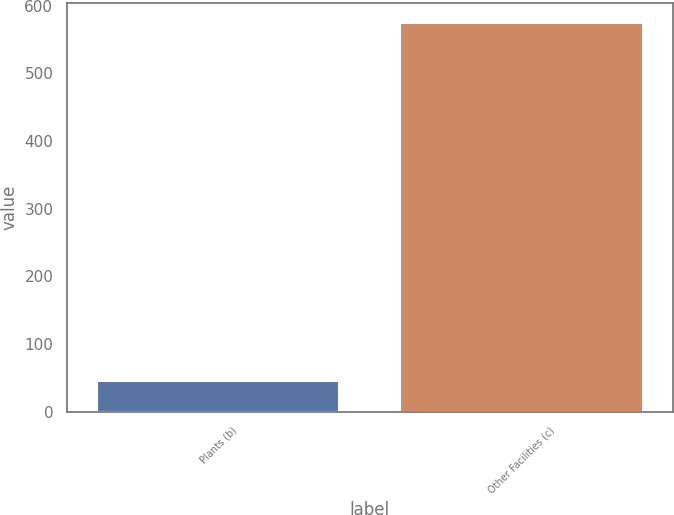Convert chart. <chart><loc_0><loc_0><loc_500><loc_500><bar_chart><fcel>Plants (b)<fcel>Other Facilities (c)<nl><fcel>45<fcel>575<nl></chart> 